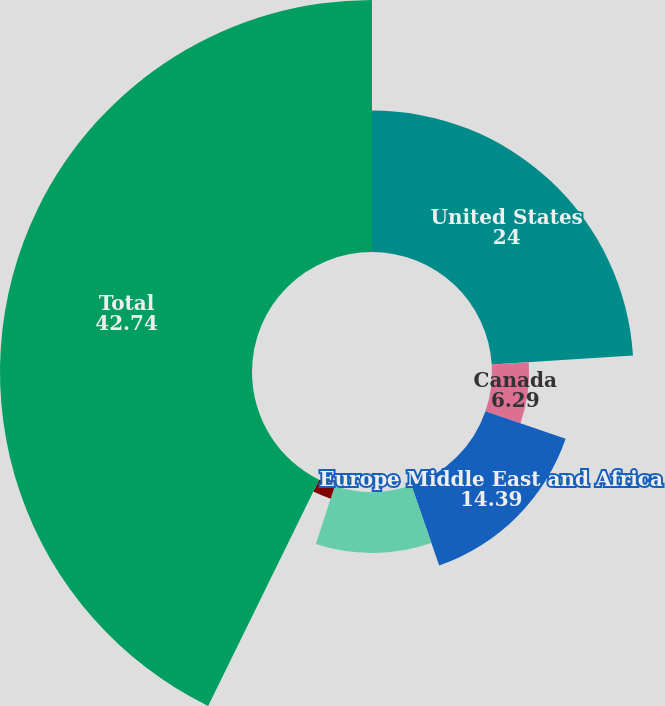<chart> <loc_0><loc_0><loc_500><loc_500><pie_chart><fcel>United States<fcel>Canada<fcel>Europe Middle East and Africa<fcel>Asia-Pacific<fcel>Latin America<fcel>Total<nl><fcel>24.0%<fcel>6.29%<fcel>14.39%<fcel>10.34%<fcel>2.24%<fcel>42.74%<nl></chart> 